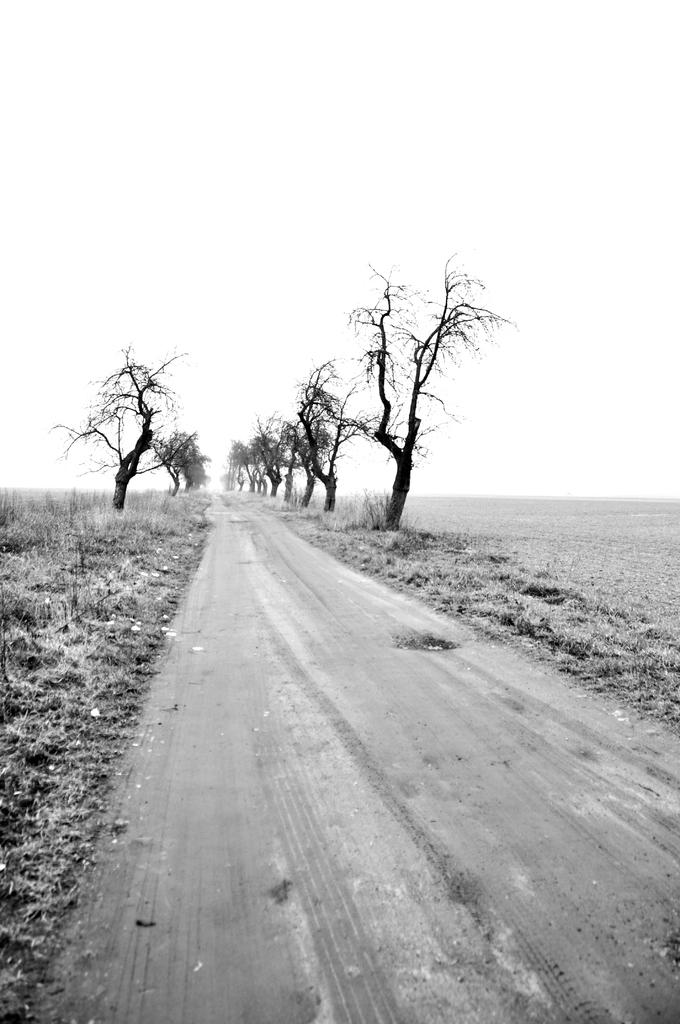What is the color scheme of the image? The image is black and white. What can be seen in the center of the image? There are trees in the center of the image. What type of vegetation is at the bottom of the image? There is grass at the bottom of the image. What is located at the bottom of the image alongside the grass? There is a road at the bottom of the image. What is visible at the top of the image? The sky is visible at the top of the image. Where are the ants crawling on the stove in the image? There are no ants or stove present in the image. What type of roll is visible in the image? There is no roll present in the image. 